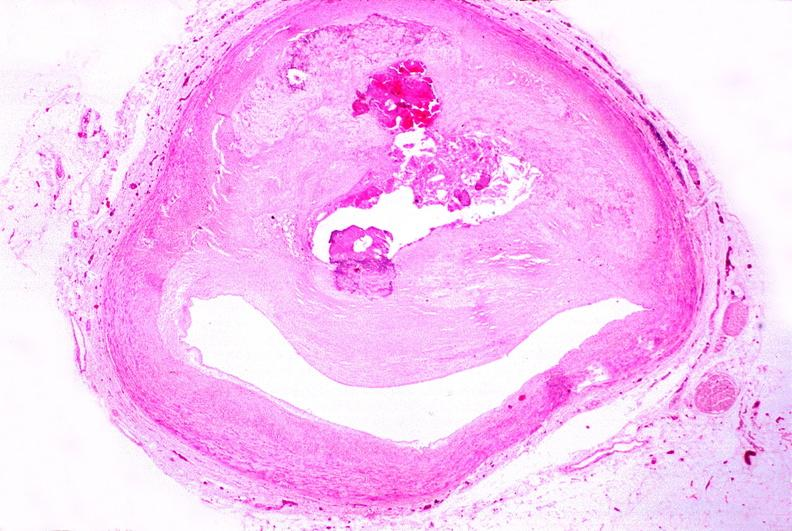what is atherosclerosis left?
Answer the question using a single word or phrase. Anterior descending coronary artery 